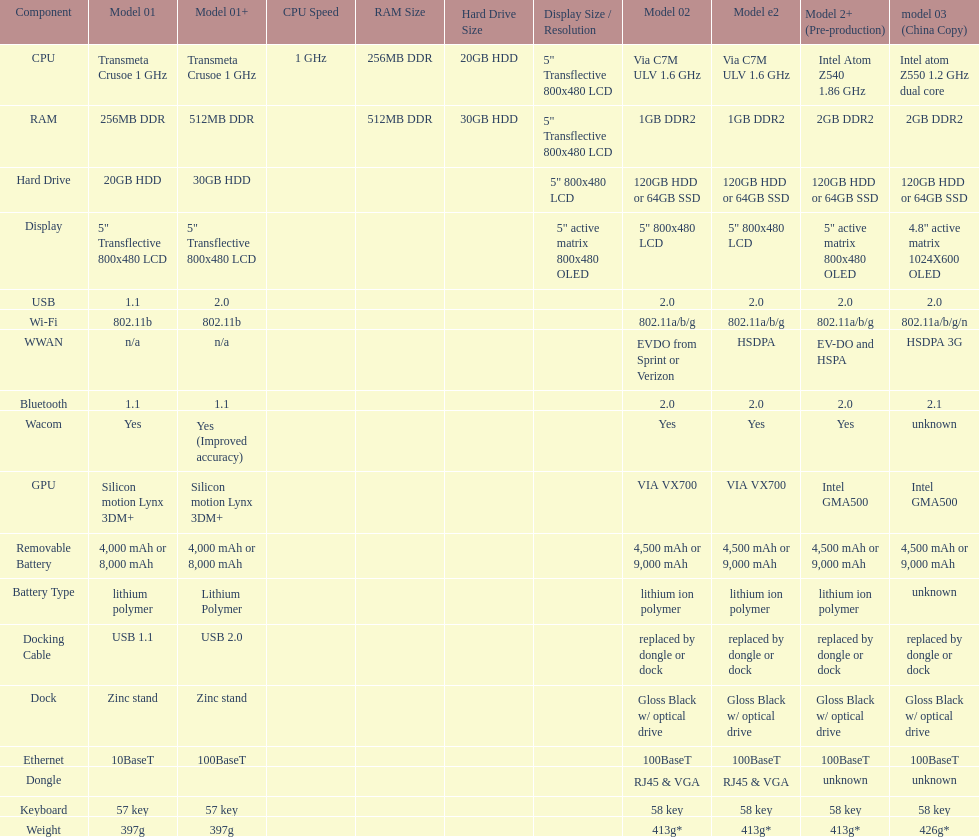What is the total number of components on the chart? 18. 